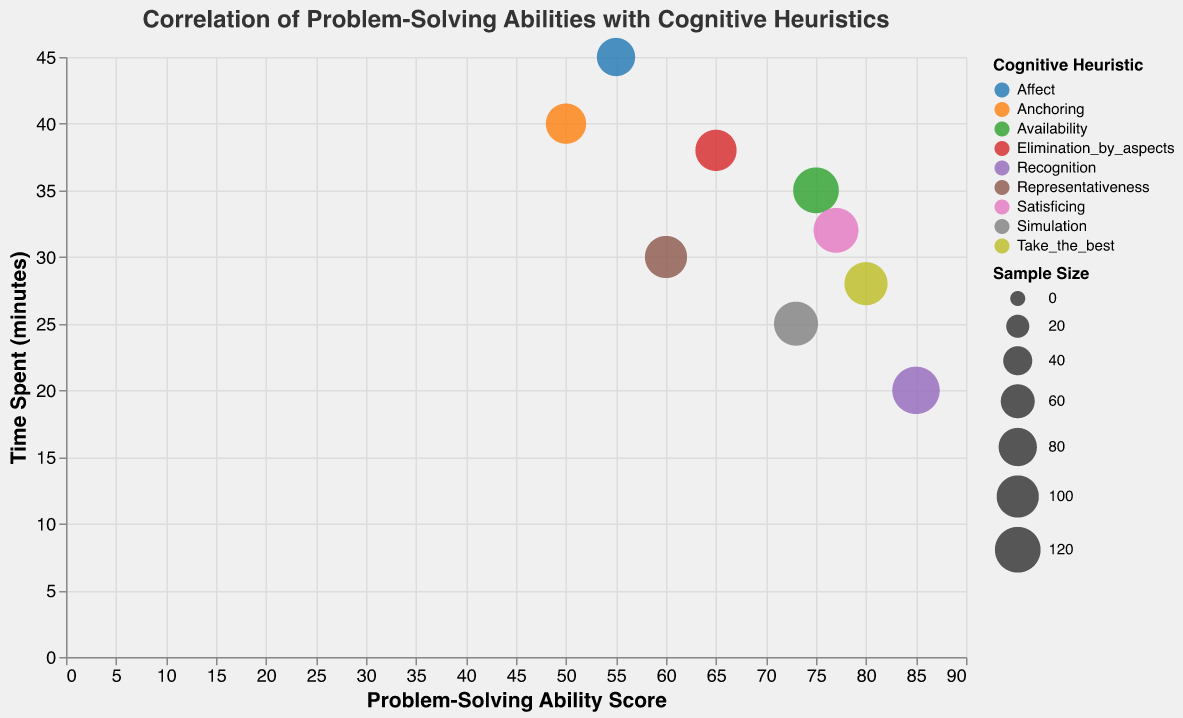What is the title of the chart? The title of the chart is prominently displayed at the top of the figure. It reads "Correlation of Problem-Solving Abilities with Cognitive Heuristics."
Answer: Correlation of Problem-Solving Abilities with Cognitive Heuristics Which cognitive heuristic has the highest Problem-Solving Ability Score? By observing the x-axis, the heuristic with the data point farthest to the right has the highest score. The data point for "Recognition" is at 85.
Answer: Recognition What is the size of the sample associated with the heuristic "Affect"? The size of the bubbles represents the sample size. From the tooltip or legend, the "Affect" heuristic has a sample size of 80.
Answer: 80 Which heuristic corresponds to the largest bubble in the chart? The largest bubble in the chart, which represents the biggest sample size, belongs to the "Recognition" heuristic, visible by its relatively bigger size and noted sample size in the tooltip.
Answer: Recognition Which heuristics have a Problem-Solving Ability Score greater than 70? By looking at the x-axis, the heuristics with problem-solving scores greater than 70 are "Availability" (75), "Recognition" (85), "Simulation" (73), "Satisficing" (77), and "Take_the_best" (80).
Answer: Availability, Recognition, Simulation, Satisficing, Take_the_best What is the average Problem-Solving Ability Score of "Availability" and "Anchoring"? The scores for "Availability" and "Anchoring" are 75 and 50, respectively. Add these scores and divide by 2: (75 + 50)/2 = 62.5.
Answer: 62.5 Which heuristic spent the least time on problem-solving? From the y-axis, the heuristic with the data point closest to the origin indicates the least time spent. "Recognition" has a Time Spent of 20 minutes.
Answer: Recognition Compare the Time Spent between "Satisficing" and "Take the best". Which is greater? By comparing their positions along the y-axis or checking tooltips, "Satisficing" has 32 minutes, and "Take the best" has 28 minutes. "Satisficing" has a greater Time Spent.
Answer: Satisficing How does the Sample Size for "Elimination by aspects" compare with "Representativeness"? Checking the tooltip, "Elimination by aspects" has a sample size of 95, and "Representativeness" has a sample size of 100. "Representativeness" has a larger sample size.
Answer: Representativeness What is the difference in the Problem-Solving Ability Score between "Recognition" and "Affect"? "Recognition" has a score of 85, and "Affect" has a score of 55. The difference is 85 - 55 = 30.
Answer: 30 